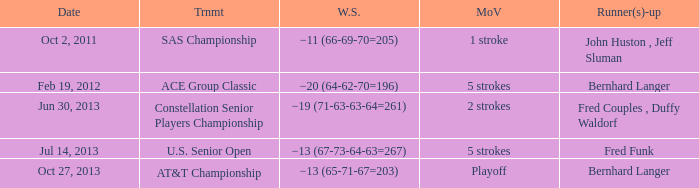Which Margin of victory has a Tournament of u.s. senior open? 5 strokes. 